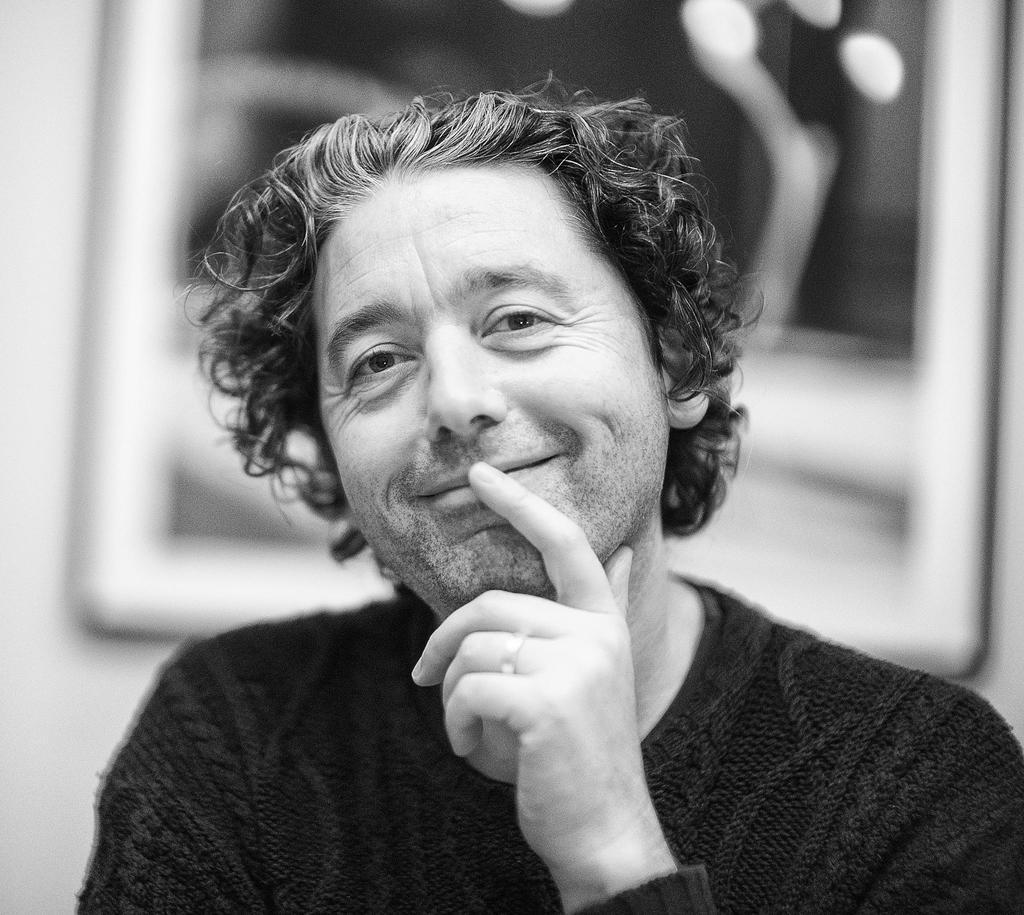Who is present in the image? There is a man in the image. What is the man wearing? The man is wearing a sweatshirt. What expression does the man have? The man is smiling. What can be seen on the wall in the background of the image? There is a frame on the wall in the background of the image. What time of day is it in the image, and how long will it take for the thing to smash? There is no indication of the time of day in the image, and no "thing" is present to smash. 